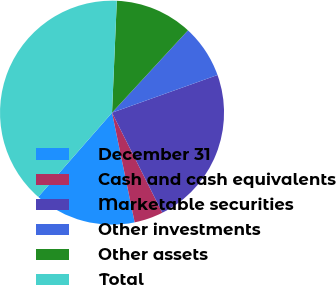Convert chart to OTSL. <chart><loc_0><loc_0><loc_500><loc_500><pie_chart><fcel>December 31<fcel>Cash and cash equivalents<fcel>Marketable securities<fcel>Other investments<fcel>Other assets<fcel>Total<nl><fcel>14.69%<fcel>4.17%<fcel>23.05%<fcel>7.68%<fcel>11.18%<fcel>39.23%<nl></chart> 